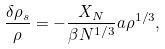<formula> <loc_0><loc_0><loc_500><loc_500>\frac { \delta \rho _ { s } } { \rho } = - \frac { X _ { N } } { \beta N ^ { 1 / 3 } } a \rho ^ { 1 / 3 } ,</formula> 